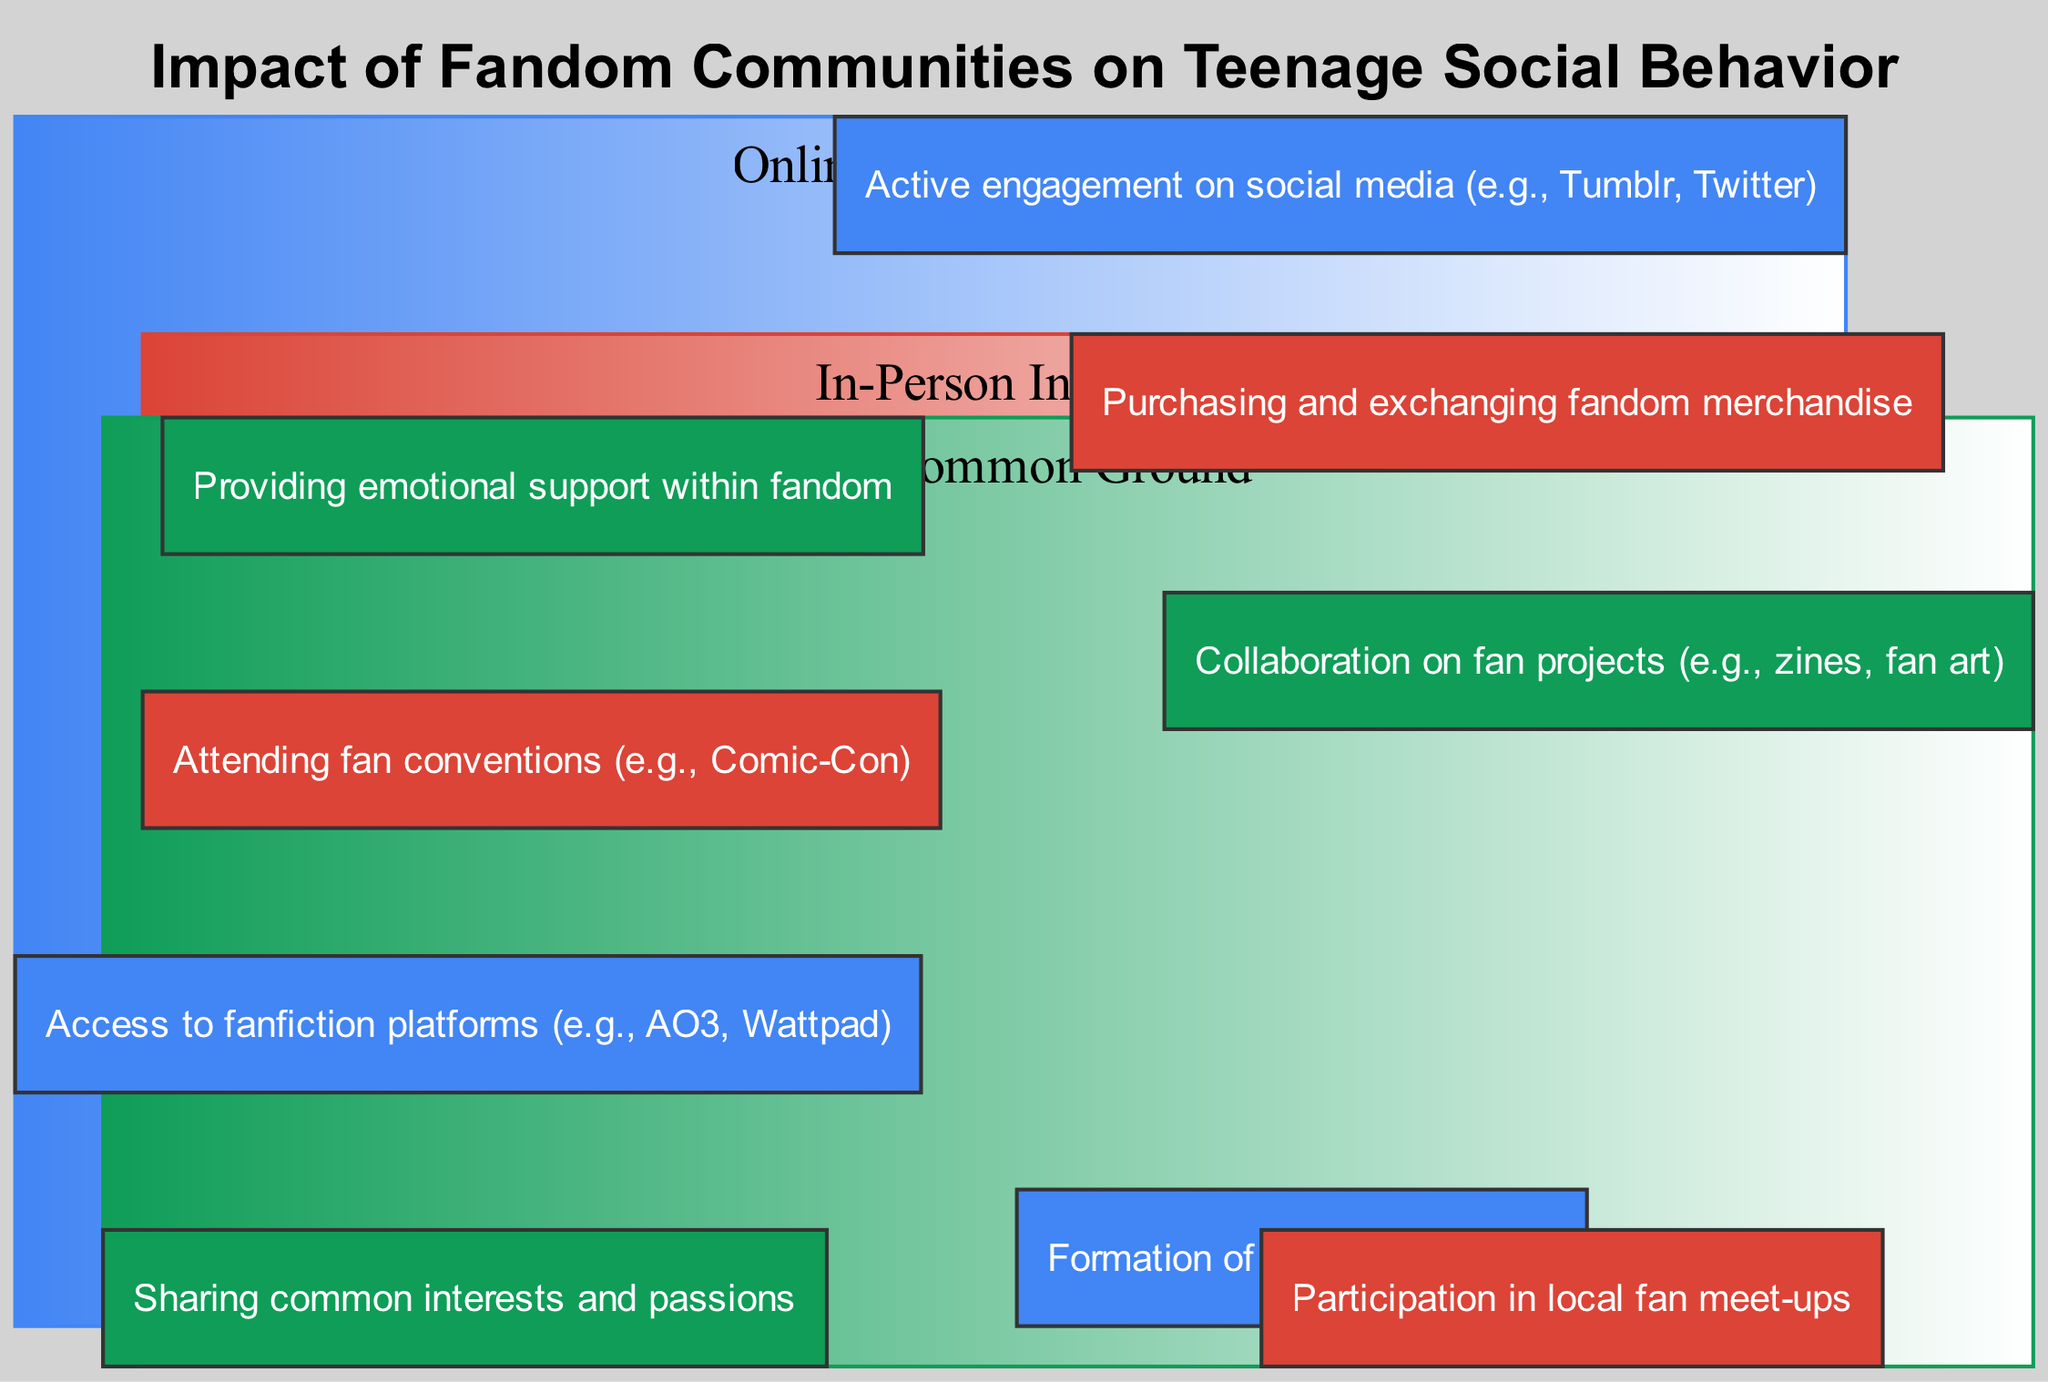What are the elements of Online Interactions? According to the diagram sections, the elements listed under Online Interactions are "Access to fanfiction platforms (e.g., AO3, Wattpad)", "Formation of virtual friendships", and "Active engagement on social media (e.g., Tumblr, Twitter)".
Answer: Access to fanfiction platforms (e.g., AO3, Wattpad), Formation of virtual friendships, Active engagement on social media (e.g., Tumblr, Twitter) How many elements are in In-Person Interactions? The section titled In-Person Interactions contains three distinct elements: "Attending fan conventions (e.g., Comic-Con)", "Participation in local fan meet-ups", and "Purchasing and exchanging fandom merchandise". Therefore, there are three elements in total.
Answer: 3 What is a common element between Online and In-Person Interactions? The Common Ground section highlights shared interests and passions, emotional support within the fandom, and collaboration on fan projects. These elements represent interactions that can occur in both online and in-person contexts, indicating that emotional support via fandom is a shared characteristic.
Answer: Sharing common interests and passions What is the relationship between social media engagement and local meet-ups? From the structure of the diagram, social media engagement is part of Online Interactions, while local meet-ups belong to In-Person Interactions. The invisible edge drawn between these two elements suggests a connection; teenagers who engage socially online are likely to seek in-person meet-ups based on those interactions.
Answer: Connection via engagement leading to meet-ups What does the Common Ground indicate about the impact of fandoms? The Common Ground section comprises elements such as sharing common interests, community support, and collaborative projects, suggesting that fandoms facilitate social behavior that contributes to emotional well-being and creativity among teenagers. Thus, fandoms create a nurturing community environment, impacting social behavior positively.
Answer: Positive impact on social behavior What type of community support is indicated in the diagram? The diagram explicitly mentions "Providing emotional support within fandom" as a form of community support, which is essential in fostering a supportive atmosphere in fandom communities. Therefore, emotional support is the type highlighted.
Answer: Providing emotional support within fandom How do collaborative projects influence online interactions? Looking at the Common Ground section, collaboration on fan projects like zines and fan art indicates that these projects stem from online interactions, emphasizing the connection and cooperation among teen fans. This suggests that these projects enhance the quality of online engagements.
Answer: Enhance online engagements Which element emphasizes the importance of live events in fandoms? The element "Attending fan conventions (e.g., Comic-Con)" under In-Person Interactions specifically spotlights live events as a critical part of the fandom experience, showcasing how in-person gatherings contribute to social behaviors among teenagers in fandom communities.
Answer: Attending fan conventions (e.g., Comic-Con) 